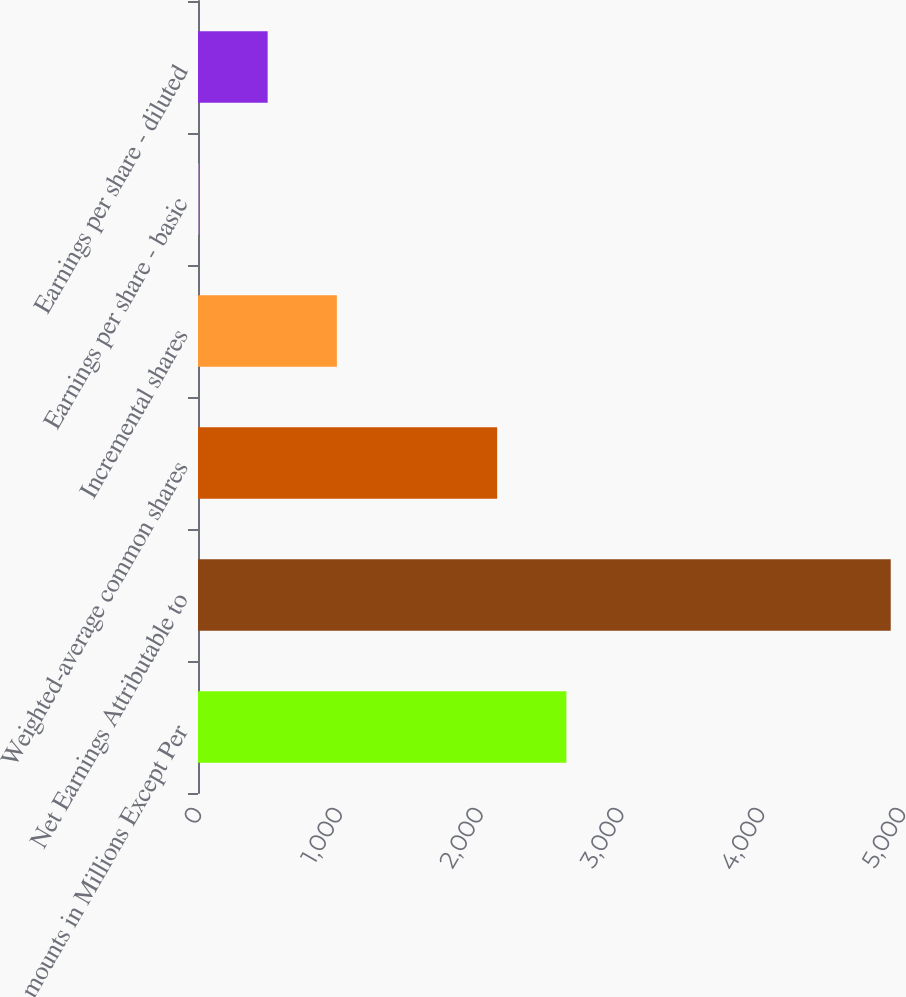Convert chart to OTSL. <chart><loc_0><loc_0><loc_500><loc_500><bar_chart><fcel>Amounts in Millions Except Per<fcel>Net Earnings Attributable to<fcel>Weighted-average common shares<fcel>Incremental shares<fcel>Earnings per share - basic<fcel>Earnings per share - diluted<nl><fcel>2616.4<fcel>4920<fcel>2124.7<fcel>986.41<fcel>3.01<fcel>494.71<nl></chart> 